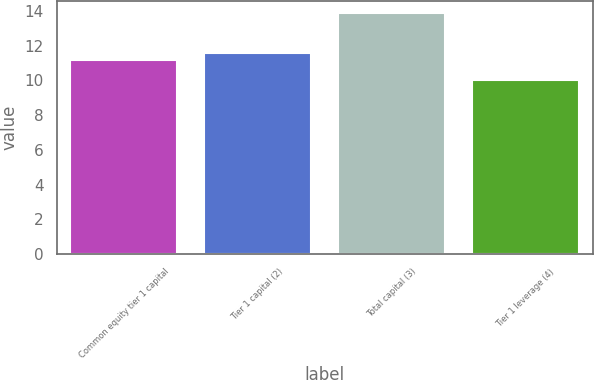Convert chart. <chart><loc_0><loc_0><loc_500><loc_500><bar_chart><fcel>Common equity tier 1 capital<fcel>Tier 1 capital (2)<fcel>Total capital (3)<fcel>Tier 1 leverage (4)<nl><fcel>11.2<fcel>11.59<fcel>13.9<fcel>10<nl></chart> 